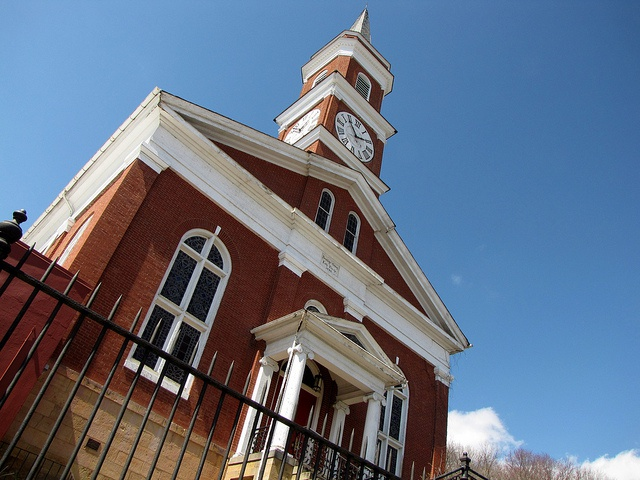Describe the objects in this image and their specific colors. I can see clock in darkgray, gray, and black tones and clock in darkgray, white, and lightgray tones in this image. 